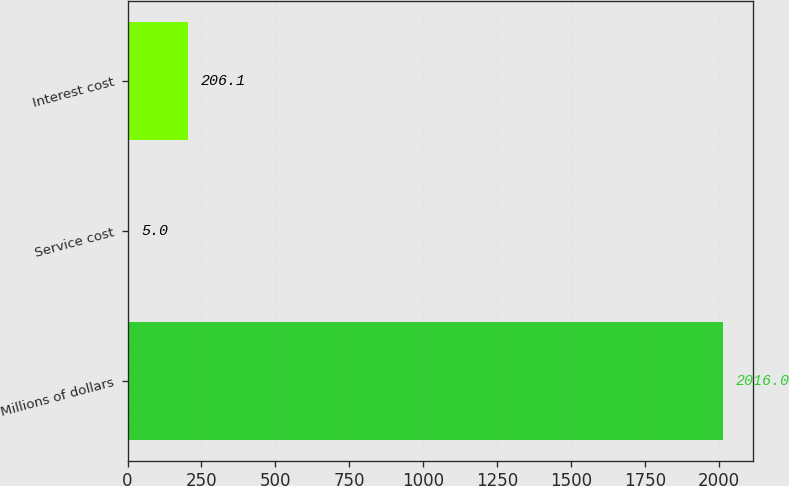Convert chart to OTSL. <chart><loc_0><loc_0><loc_500><loc_500><bar_chart><fcel>Millions of dollars<fcel>Service cost<fcel>Interest cost<nl><fcel>2016<fcel>5<fcel>206.1<nl></chart> 